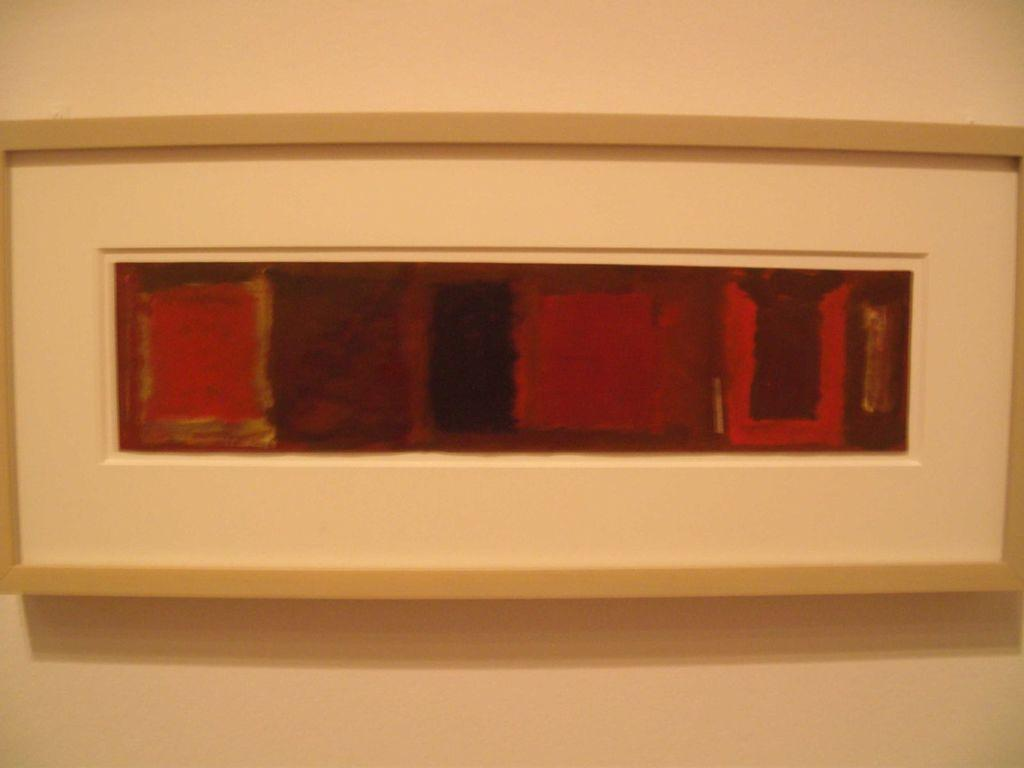What object can be seen in the image that typically holds a photograph or artwork? There is a picture frame in the image. Where is the picture frame located in the image? The picture frame is on a wall. Are there any plants growing inside the picture frame in the image? No, there are no plants growing inside the picture frame in the image. 